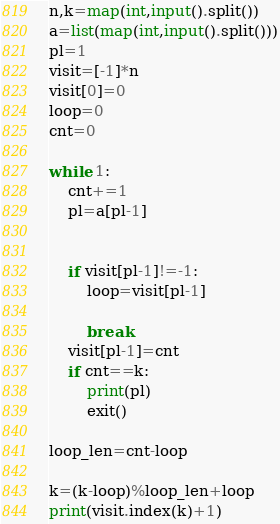Convert code to text. <code><loc_0><loc_0><loc_500><loc_500><_Python_>n,k=map(int,input().split())
a=list(map(int,input().split()))
pl=1
visit=[-1]*n
visit[0]=0
loop=0
cnt=0

while 1:
    cnt+=1
    pl=a[pl-1]
    
    
    if visit[pl-1]!=-1:
        loop=visit[pl-1]
        
        break
    visit[pl-1]=cnt
    if cnt==k:
        print(pl)
        exit()

loop_len=cnt-loop

k=(k-loop)%loop_len+loop
print(visit.index(k)+1)
</code> 